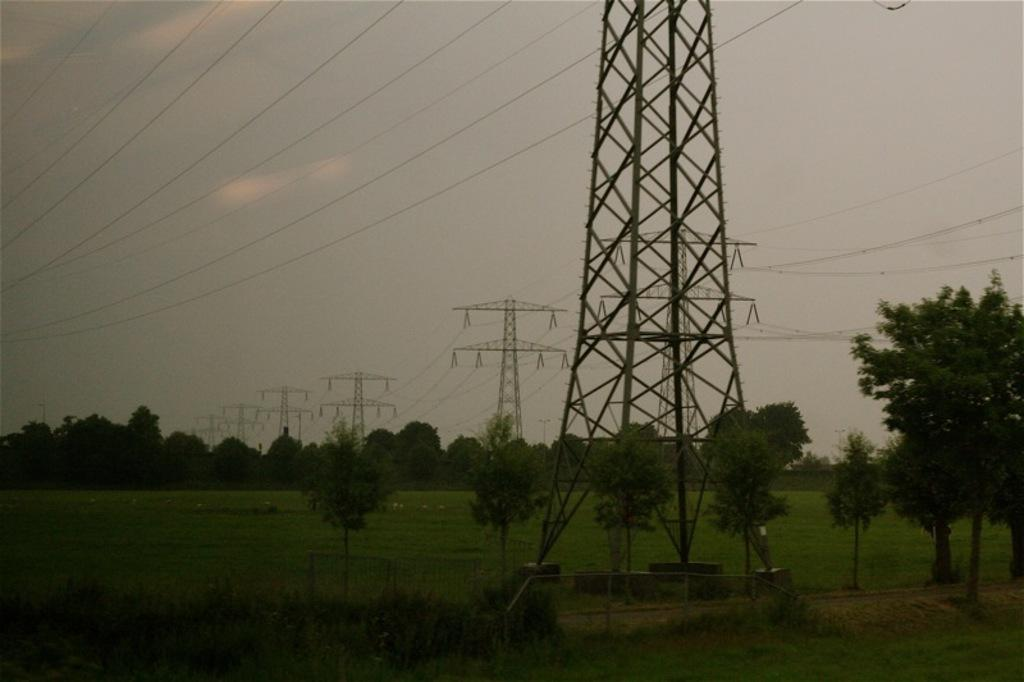What type of vegetation is present in the image? There are trees and grass in the image. What structures can be seen in the image? There are towers with wires in the image. What is visible in the background of the image? The sky is visible in the background of the image. Can you tell me how many gallons of milk are being poured from the towers in the image? There is no milk or pouring action present in the image; it features towers with wires. How many people are sneezing in the image? There are no people or sneezing actions present in the image; it features trees, grass, towers with wires, and the sky. 